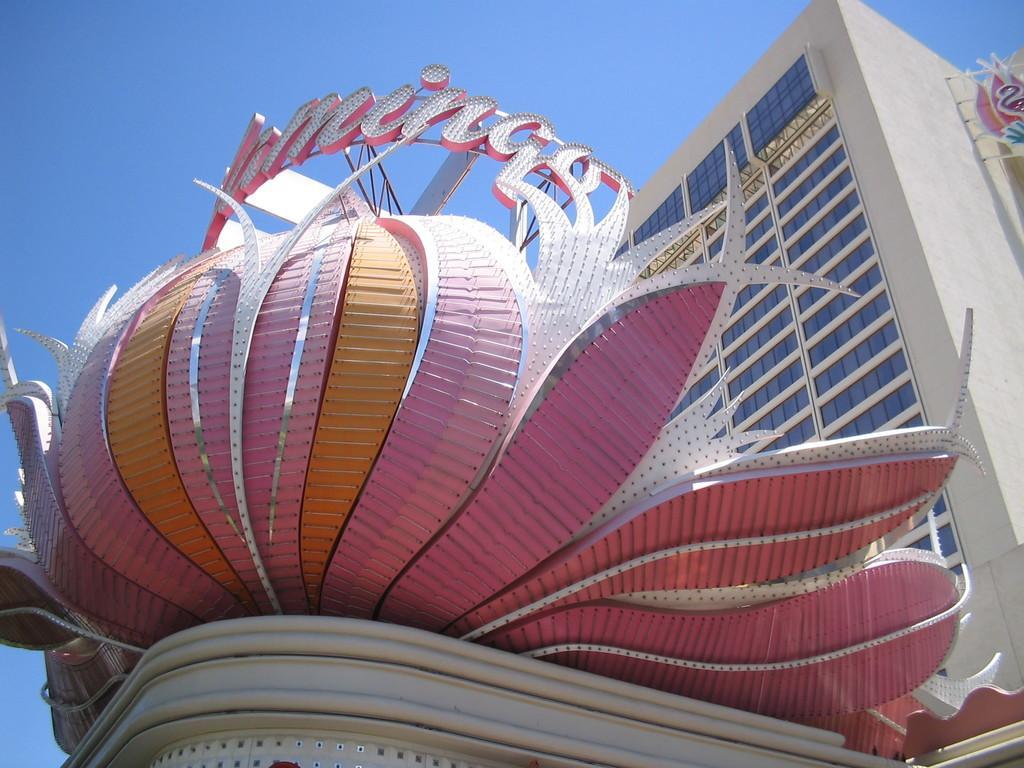Please provide a concise description of this image. In this picture we can see a building and in the background we can see the sky. 